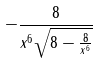Convert formula to latex. <formula><loc_0><loc_0><loc_500><loc_500>- \frac { 8 } { x ^ { 6 } \sqrt { 8 - \frac { 8 } { x ^ { 6 } } } }</formula> 